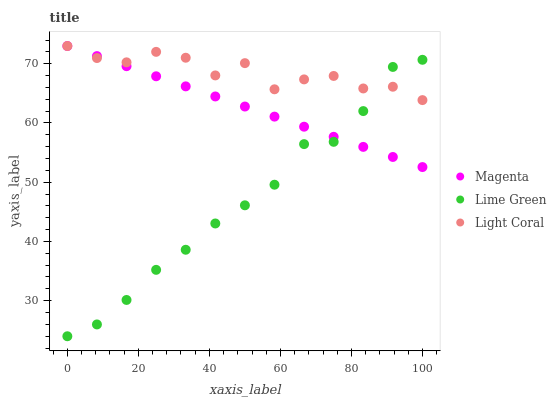Does Lime Green have the minimum area under the curve?
Answer yes or no. Yes. Does Light Coral have the maximum area under the curve?
Answer yes or no. Yes. Does Magenta have the minimum area under the curve?
Answer yes or no. No. Does Magenta have the maximum area under the curve?
Answer yes or no. No. Is Magenta the smoothest?
Answer yes or no. Yes. Is Light Coral the roughest?
Answer yes or no. Yes. Is Lime Green the smoothest?
Answer yes or no. No. Is Lime Green the roughest?
Answer yes or no. No. Does Lime Green have the lowest value?
Answer yes or no. Yes. Does Magenta have the lowest value?
Answer yes or no. No. Does Magenta have the highest value?
Answer yes or no. Yes. Does Lime Green have the highest value?
Answer yes or no. No. Does Magenta intersect Light Coral?
Answer yes or no. Yes. Is Magenta less than Light Coral?
Answer yes or no. No. Is Magenta greater than Light Coral?
Answer yes or no. No. 